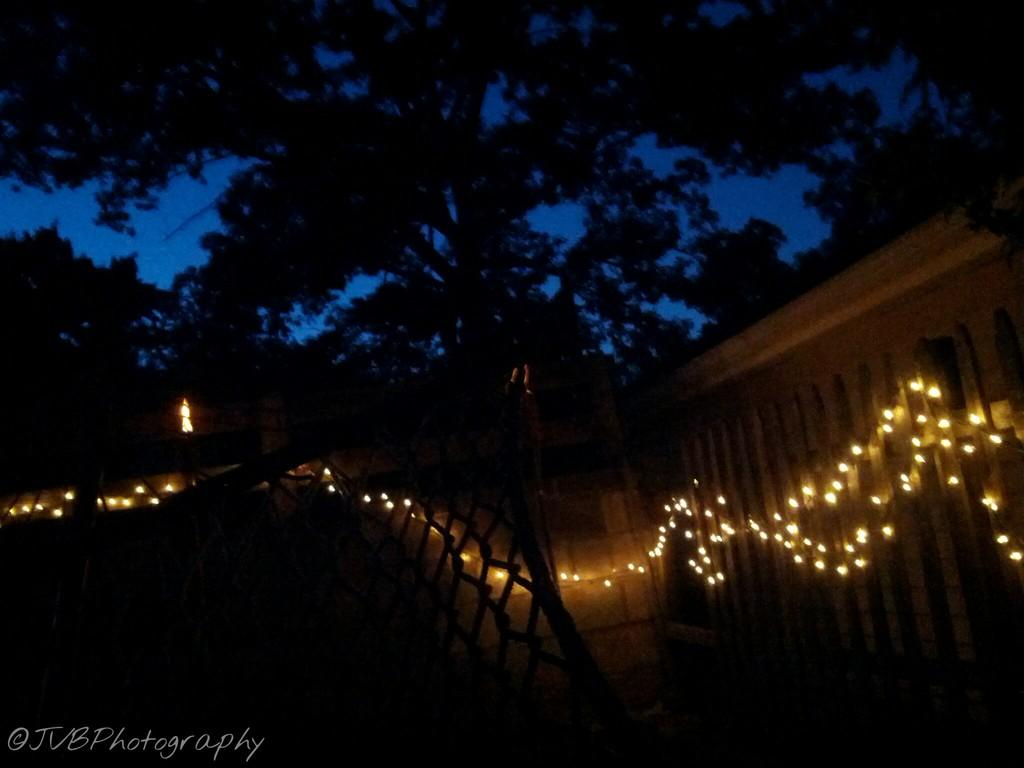What is the main feature of the wall in the image? The wall in the image is decorated with lights. What can be seen behind the wall in the image? There are trees behind the wall in the image. Is there any text present in the image? Yes, there is text at the bottom of the image. What type of mine is visible in the image? There is no mine present in the image; it features a wall decorated with lights and trees in the background. How many cattle can be seen grazing in the image? There are no cattle present in the image. 